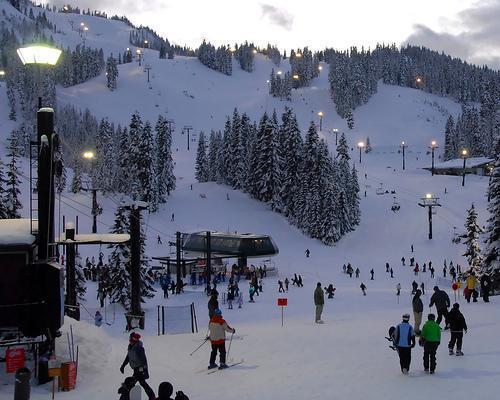How many people are wearing green coats?
Give a very brief answer. 1. 